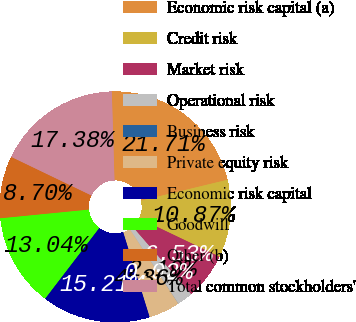Convert chart. <chart><loc_0><loc_0><loc_500><loc_500><pie_chart><fcel>Economic risk capital (a)<fcel>Credit risk<fcel>Market risk<fcel>Operational risk<fcel>Business risk<fcel>Private equity risk<fcel>Economic risk capital<fcel>Goodwill<fcel>Other (b)<fcel>Total common stockholders'<nl><fcel>21.71%<fcel>10.87%<fcel>6.53%<fcel>2.19%<fcel>0.02%<fcel>4.36%<fcel>15.21%<fcel>13.04%<fcel>8.7%<fcel>17.38%<nl></chart> 